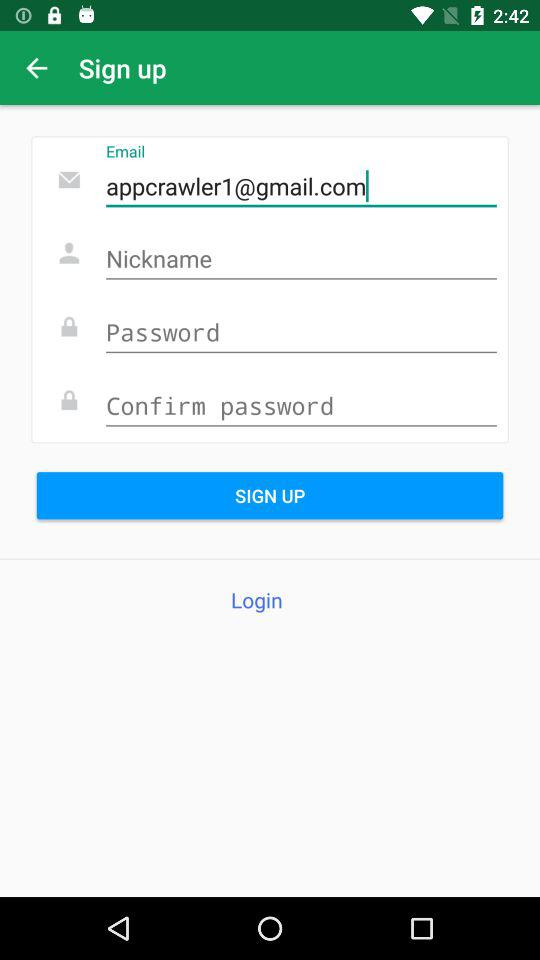What is the email address? The email address is appcrawler1@gmail.com. 